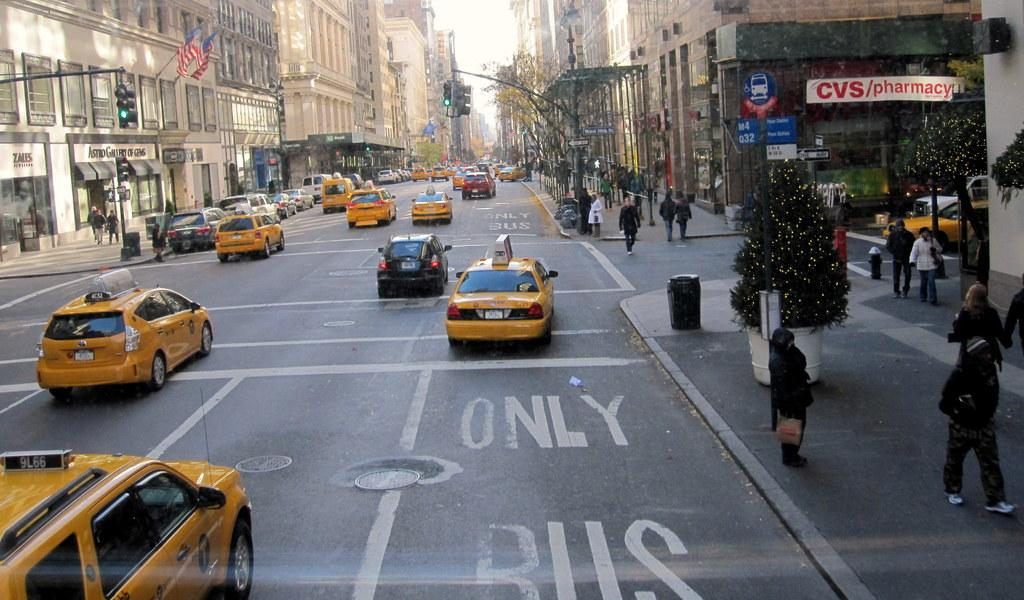<image>
Provide a brief description of the given image. The bus stop by CVS is handicap accessible and seating only. 